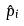<formula> <loc_0><loc_0><loc_500><loc_500>\hat { p } _ { i }</formula> 